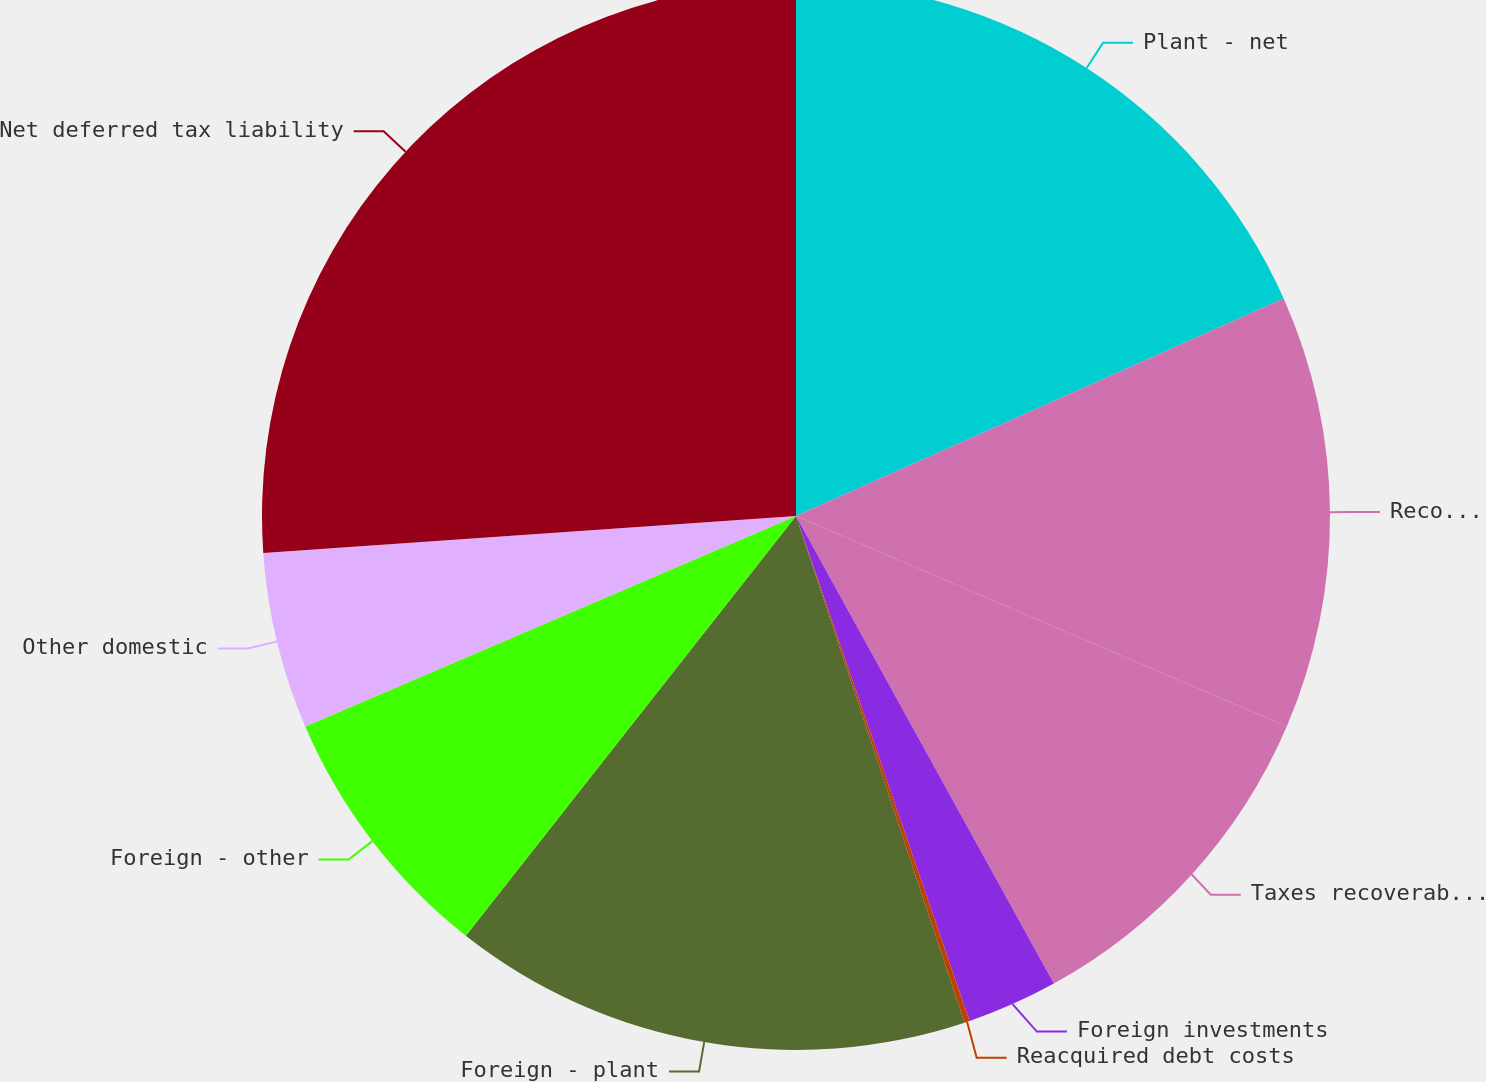Convert chart to OTSL. <chart><loc_0><loc_0><loc_500><loc_500><pie_chart><fcel>Plant - net<fcel>Recoverable transition costs<fcel>Taxes recoverable through<fcel>Foreign investments<fcel>Reacquired debt costs<fcel>Foreign - plant<fcel>Foreign - other<fcel>Other domestic<fcel>Net deferred tax liability<nl><fcel>18.32%<fcel>13.13%<fcel>10.53%<fcel>2.75%<fcel>0.16%<fcel>15.72%<fcel>7.94%<fcel>5.35%<fcel>26.1%<nl></chart> 